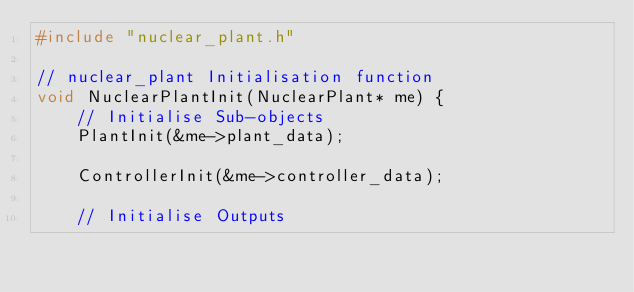<code> <loc_0><loc_0><loc_500><loc_500><_C_>#include "nuclear_plant.h"

// nuclear_plant Initialisation function
void NuclearPlantInit(NuclearPlant* me) {
    // Initialise Sub-objects
    PlantInit(&me->plant_data);

    ControllerInit(&me->controller_data);

    // Initialise Outputs</code> 